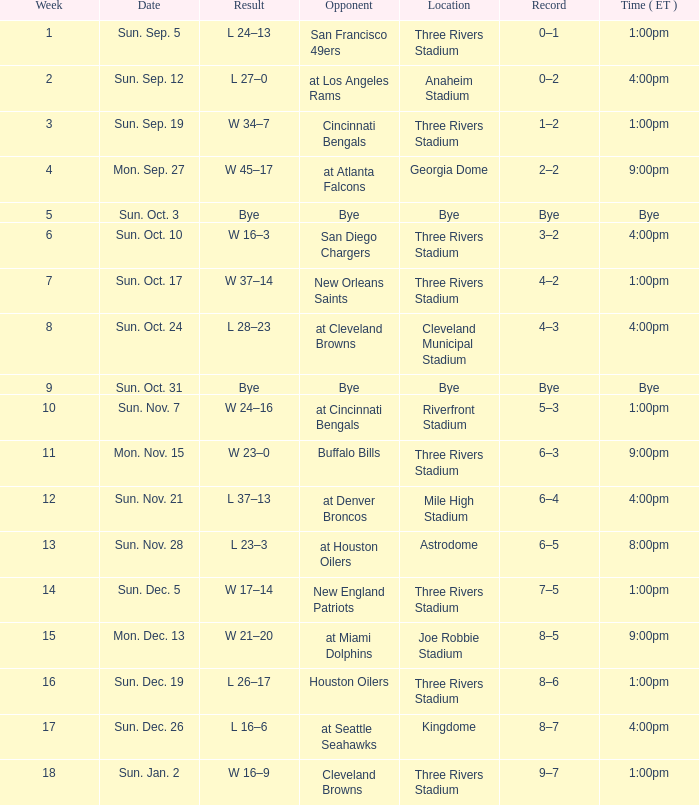What is the average Week for the game at three rivers stadium, with a Record of 3–2? 6.0. 